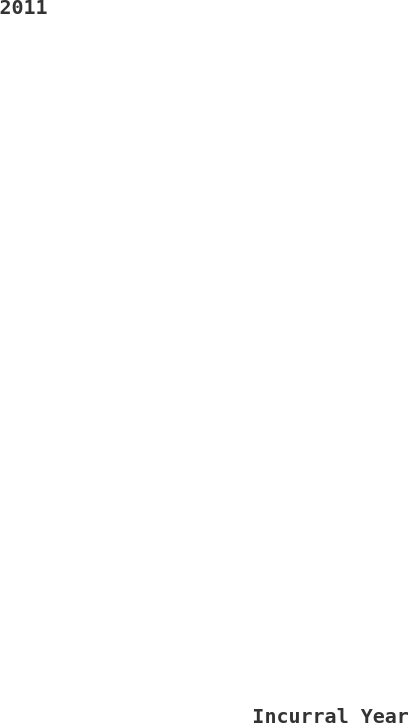Convert chart to OTSL. <chart><loc_0><loc_0><loc_500><loc_500><pie_chart><fcel>Incurral Year<fcel>2011<nl><fcel>94.46%<fcel>5.54%<nl></chart> 